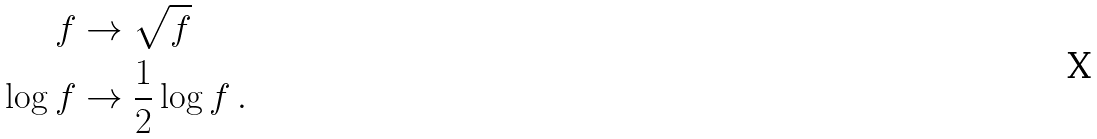<formula> <loc_0><loc_0><loc_500><loc_500>f & \rightarrow \sqrt { f } \\ \log f & \rightarrow \frac { 1 } { 2 } \log f \, .</formula> 